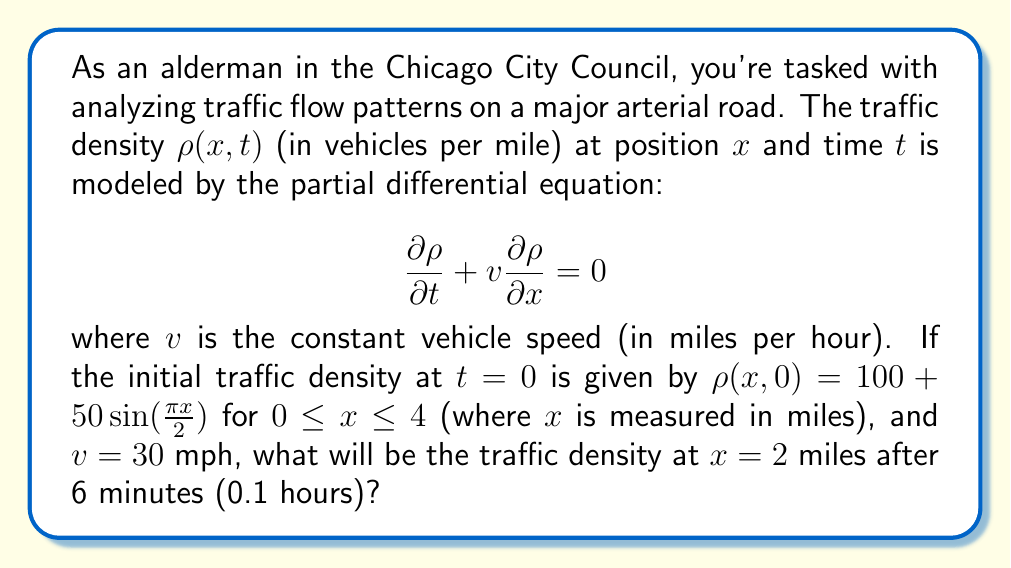Could you help me with this problem? To solve this problem, we need to use the method of characteristics for the given partial differential equation (PDE). The steps are as follows:

1) The general solution to the PDE $\frac{\partial \rho}{\partial t} + v \frac{\partial \rho}{\partial x} = 0$ is:

   $\rho(x,t) = f(x - vt)$

   where $f$ is an arbitrary function determined by the initial conditions.

2) From the initial condition, we know that:

   $\rho(x,0) = 100 + 50 \sin(\frac{\pi x}{2}) = f(x)$

3) Therefore, the complete solution is:

   $\rho(x,t) = 100 + 50 \sin(\frac{\pi (x-vt)}{2})$

4) Now, we need to find $\rho(2, 0.1)$. Let's substitute the values:
   
   $x = 2$ miles
   $t = 0.1$ hours
   $v = 30$ mph

5) Plugging these into our solution:

   $\rho(2, 0.1) = 100 + 50 \sin(\frac{\pi (2-30*0.1)}{2})$
                 $= 100 + 50 \sin(\frac{\pi (2-3)}{2})$
                 $= 100 + 50 \sin(-\frac{\pi}{2})$
                 $= 100 - 50$
                 $= 50$

Thus, the traffic density at $x = 2$ miles after 6 minutes will be 50 vehicles per mile.
Answer: 50 vehicles per mile 